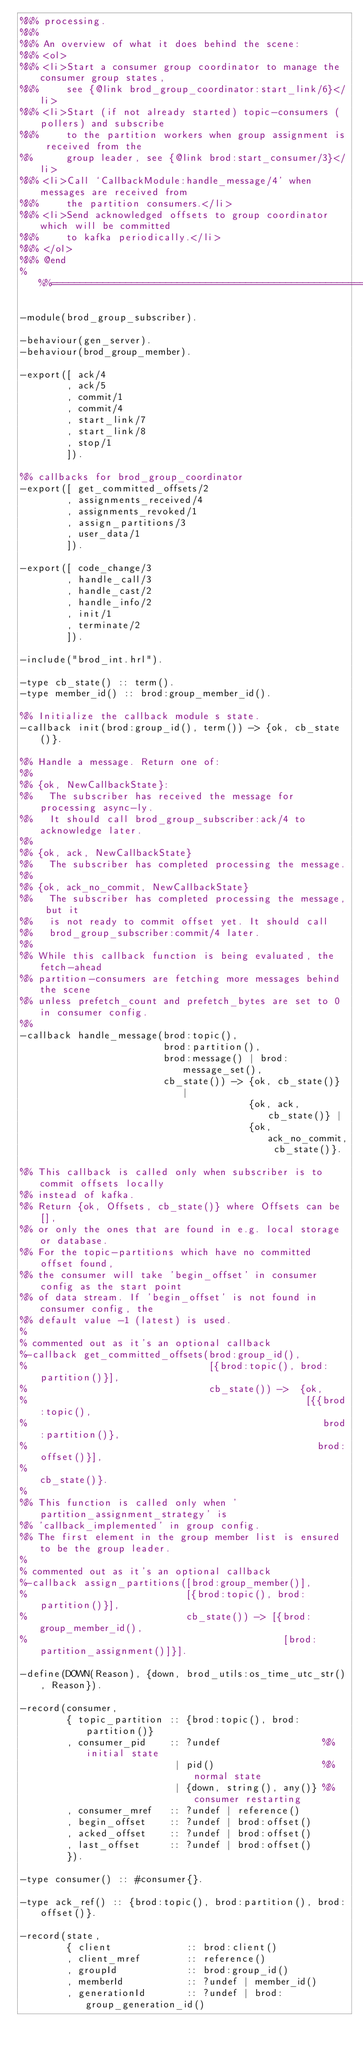Convert code to text. <code><loc_0><loc_0><loc_500><loc_500><_Erlang_>%%% processing.
%%%
%%% An overview of what it does behind the scene:
%%% <ol>
%%% <li>Start a consumer group coordinator to manage the consumer group states,
%%%     see {@link brod_group_coordinator:start_link/6}</li>
%%% <li>Start (if not already started) topic-consumers (pollers) and subscribe
%%%     to the partition workers when group assignment is received from the
%%      group leader, see {@link brod:start_consumer/3}</li>
%%% <li>Call `CallbackModule:handle_message/4' when messages are received from
%%%     the partition consumers.</li>
%%% <li>Send acknowledged offsets to group coordinator which will be committed
%%%     to kafka periodically.</li>
%%% </ol>
%%% @end
%%%=============================================================================

-module(brod_group_subscriber).

-behaviour(gen_server).
-behaviour(brod_group_member).

-export([ ack/4
        , ack/5
        , commit/1
        , commit/4
        , start_link/7
        , start_link/8
        , stop/1
        ]).

%% callbacks for brod_group_coordinator
-export([ get_committed_offsets/2
        , assignments_received/4
        , assignments_revoked/1
        , assign_partitions/3
        , user_data/1
        ]).

-export([ code_change/3
        , handle_call/3
        , handle_cast/2
        , handle_info/2
        , init/1
        , terminate/2
        ]).

-include("brod_int.hrl").

-type cb_state() :: term().
-type member_id() :: brod:group_member_id().

%% Initialize the callback module s state.
-callback init(brod:group_id(), term()) -> {ok, cb_state()}.

%% Handle a message. Return one of:
%%
%% {ok, NewCallbackState}:
%%   The subscriber has received the message for processing async-ly.
%%   It should call brod_group_subscriber:ack/4 to acknowledge later.
%%
%% {ok, ack, NewCallbackState}
%%   The subscriber has completed processing the message.
%%
%% {ok, ack_no_commit, NewCallbackState}
%%   The subscriber has completed processing the message, but it
%%   is not ready to commit offset yet. It should call
%%   brod_group_subscriber:commit/4 later.
%%
%% While this callback function is being evaluated, the fetch-ahead
%% partition-consumers are fetching more messages behind the scene
%% unless prefetch_count and prefetch_bytes are set to 0 in consumer config.
%%
-callback handle_message(brod:topic(),
                         brod:partition(),
                         brod:message() | brod:message_set(),
                         cb_state()) -> {ok, cb_state()} |
                                        {ok, ack, cb_state()} |
                                        {ok, ack_no_commit, cb_state()}.

%% This callback is called only when subscriber is to commit offsets locally
%% instead of kafka.
%% Return {ok, Offsets, cb_state()} where Offsets can be [],
%% or only the ones that are found in e.g. local storage or database.
%% For the topic-partitions which have no committed offset found,
%% the consumer will take 'begin_offset' in consumer config as the start point
%% of data stream. If 'begin_offset' is not found in consumer config, the
%% default value -1 (latest) is used.
%
% commented out as it's an optional callback
%-callback get_committed_offsets(brod:group_id(),
%                                [{brod:topic(), brod:partition()}],
%                                cb_state()) ->  {ok,
%                                                 [{{brod:topic(),
%                                                    brod:partition()},
%                                                   brod:offset()}],
%                                                 cb_state()}.
%
%% This function is called only when 'partition_assignment_strategy' is
%% 'callback_implemented' in group config.
%% The first element in the group member list is ensured to be the group leader.
%
% commented out as it's an optional callback
%-callback assign_partitions([brod:group_member()],
%                            [{brod:topic(), brod:partition()}],
%                            cb_state()) -> [{brod:group_member_id(),
%                                             [brod:partition_assignment()]}].

-define(DOWN(Reason), {down, brod_utils:os_time_utc_str(), Reason}).

-record(consumer,
        { topic_partition :: {brod:topic(), brod:partition()}
        , consumer_pid    :: ?undef                  %% initial state
                           | pid()                   %% normal state
                           | {down, string(), any()} %% consumer restarting
        , consumer_mref   :: ?undef | reference()
        , begin_offset    :: ?undef | brod:offset()
        , acked_offset    :: ?undef | brod:offset()
        , last_offset     :: ?undef | brod:offset()
        }).

-type consumer() :: #consumer{}.

-type ack_ref() :: {brod:topic(), brod:partition(), brod:offset()}.

-record(state,
        { client             :: brod:client()
        , client_mref        :: reference()
        , groupId            :: brod:group_id()
        , memberId           :: ?undef | member_id()
        , generationId       :: ?undef | brod:group_generation_id()</code> 